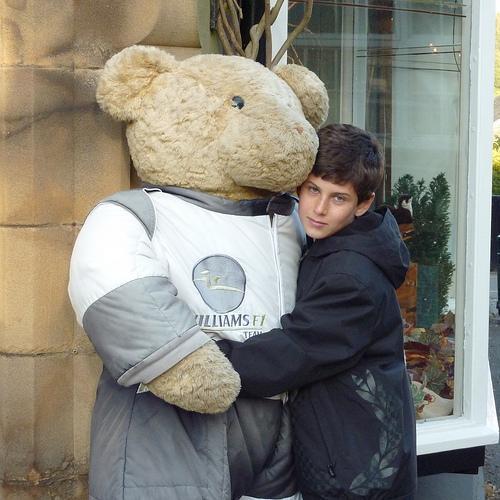Verify the accuracy of this image caption: "The person is above the teddy bear.".
Answer yes or no. No. 